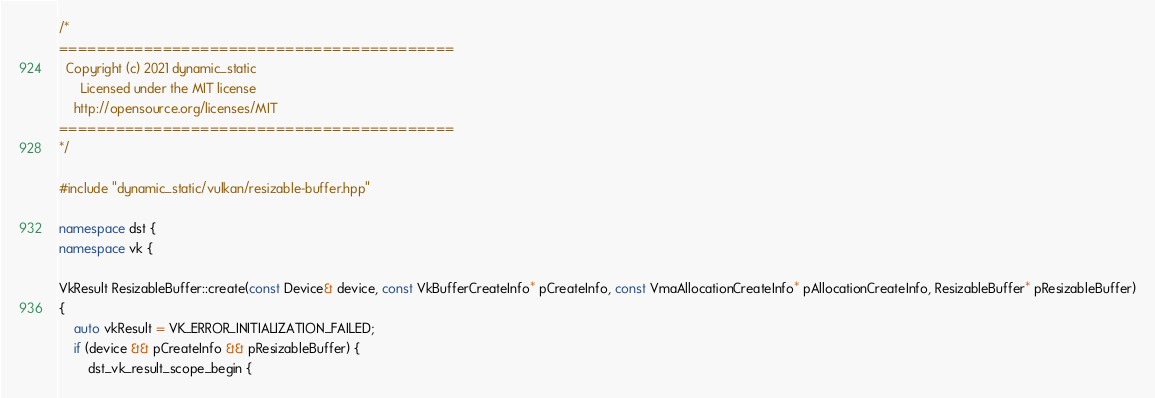<code> <loc_0><loc_0><loc_500><loc_500><_C++_>
/*
==========================================
  Copyright (c) 2021 dynamic_static
      Licensed under the MIT license
    http://opensource.org/licenses/MIT
==========================================
*/

#include "dynamic_static/vulkan/resizable-buffer.hpp"

namespace dst {
namespace vk {

VkResult ResizableBuffer::create(const Device& device, const VkBufferCreateInfo* pCreateInfo, const VmaAllocationCreateInfo* pAllocationCreateInfo, ResizableBuffer* pResizableBuffer)
{
    auto vkResult = VK_ERROR_INITIALIZATION_FAILED;
    if (device && pCreateInfo && pResizableBuffer) {
        dst_vk_result_scope_begin {</code> 